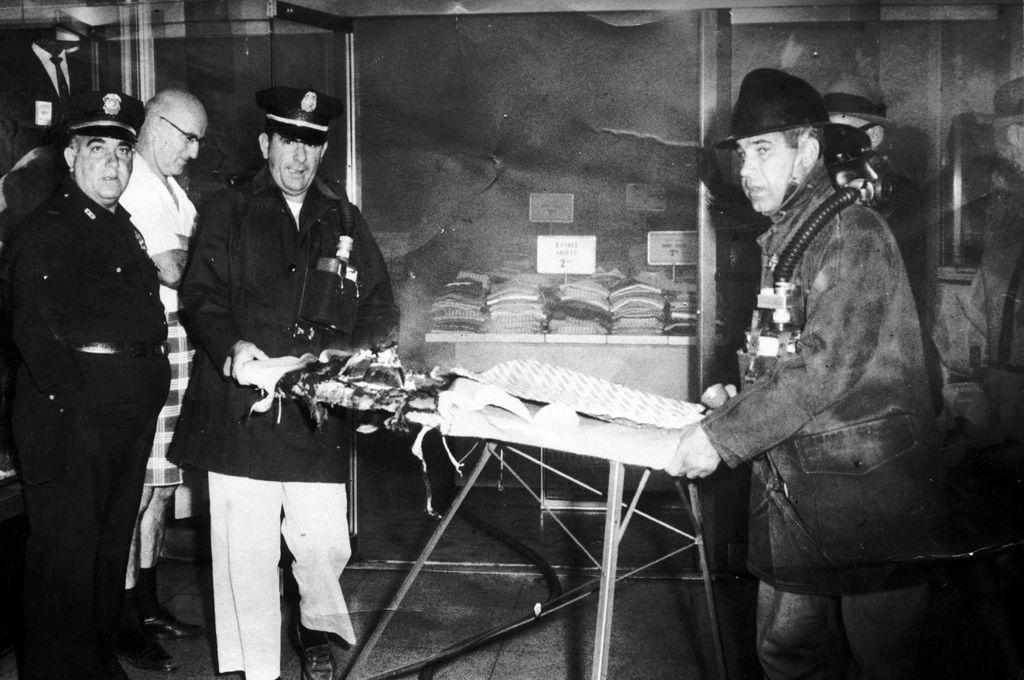Please provide a concise description of this image. In this image we can see a black and white image. In this image we can see some persons, table and other objects. In the background of the image there is a wall, name boards and other objects. 